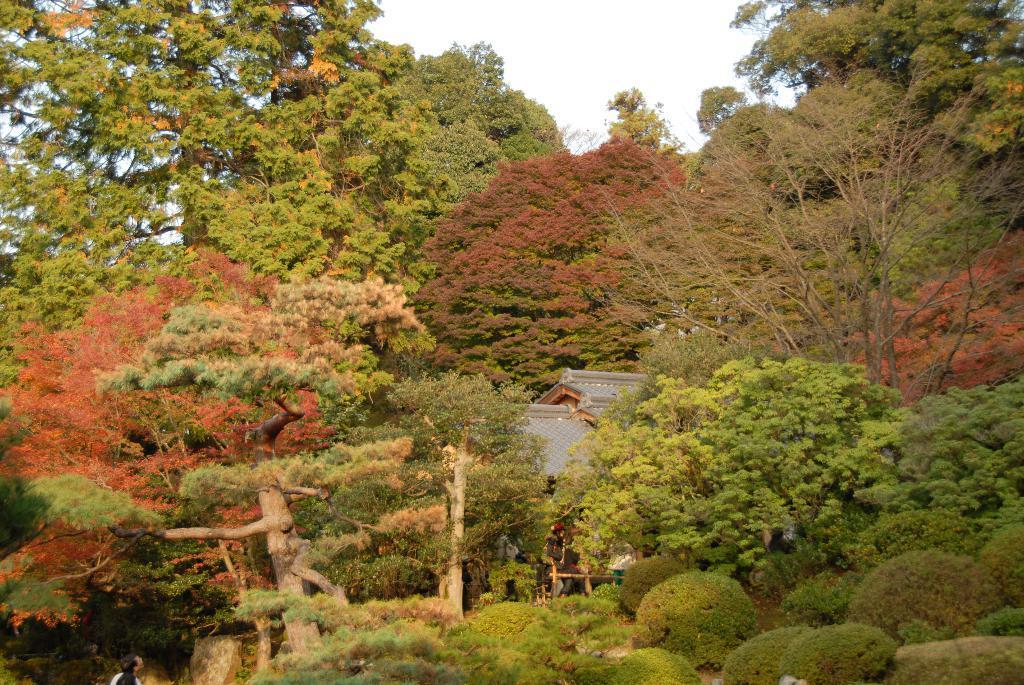Please provide a concise description of this image. In this image I can see trees, a house and a person. In the background I can see the sky. 